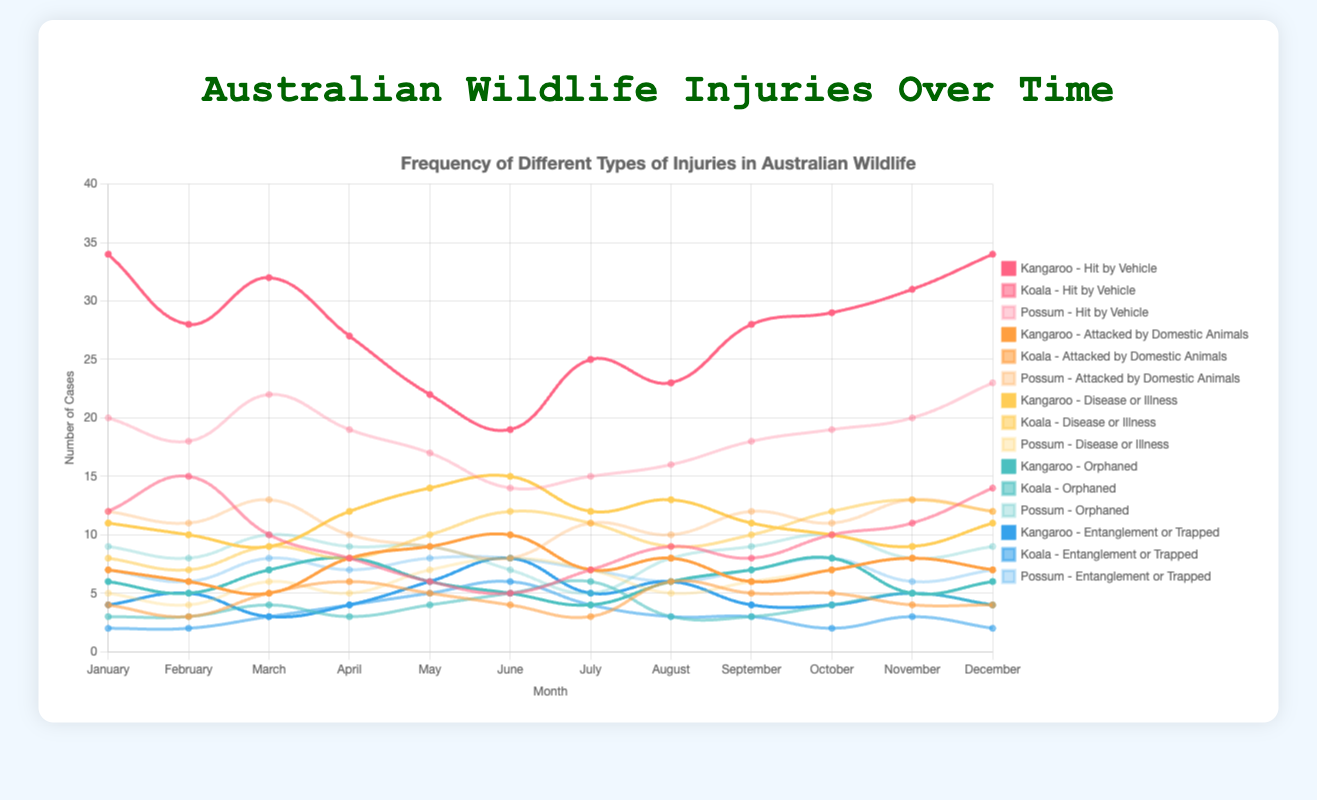Which month had the highest number of kangaroos hit by vehicles? Look at the line representing "Kangaroo - Hit by Vehicle" and identify the month with the peak value. January and December both have peak values of 34.
Answer: January, December Which injury type has the highest frequency for possums in July? Observe the different lines representing injury types for possums and find the one with the highest value in July. "Hit by Vehicle" has the highest value in July with 15 cases.
Answer: Hit by Vehicle What is the average number of koalas attacked by domestic animals over the year? Sum the monthly values for "Koala - Attacked by Domestic Animals" and divide by 12. The sum is 54, so the average is 54 / 12 = 4.5.
Answer: 4.5 Compare the number of kangaroos hit by vehicles and possums hit by vehicles in March. Which is greater and by how much? Look at the values for March for both categories. Kangaroos have 32 cases, and possums have 22 cases. The difference is 32 - 22 = 10.
Answer: Kangaroo by 10 Which species had more cases of disease or illness in October, and by how many cases? Compare the number of cases for each species under "Disease or Illness" in October. Koalas have 12 cases, kangaroos have 10, and possums have 7. The largest difference is Koala with 2 more cases than kangaroo.
Answer: Koala by 2 What is the total number of orphaned kangaroos and koalas in June? Add the June values for orphaned kangaroos (5) and koalas (5). The total is 5 + 5 = 10.
Answer: 10 What is the difference in the number of entangled or trapped possums between February and August? Subtract the February value from the August value for "Possum - Entanglement or Trapped". The values are 6 in February and 6 in August, so the difference is 6 - 6 = 0.
Answer: 0 During which month were koalas most frequently caught in entanglements or traps? Identify the peak value for "Koala - Entanglement or Trapped". The highest value is 6 in June.
Answer: June How many more kangaroos were hit by vehicles in July compared to kangaroos orphaned in the same month? Subtract the number of orphaned kangaroos in July (4) from the number hit by vehicles (25). The difference is 25 - 4 = 21.
Answer: 21 Is there any month where the number of diseases or illnesses for all three species combined exceed 30 cases? Which month? Add the monthly values for each species under "Disease or Illness" and check if the sum exceeds 30 in any month. In November, the combined cases are 9 (Kangaroo) + 13 (Koala) + 8 (Possum) = 30, exactly.
Answer: No 